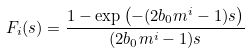Convert formula to latex. <formula><loc_0><loc_0><loc_500><loc_500>F _ { i } ( s ) = \frac { 1 - \exp \left ( - ( 2 b _ { 0 } m ^ { i } - 1 ) s \right ) } { ( 2 b _ { 0 } m ^ { i } - 1 ) s }</formula> 